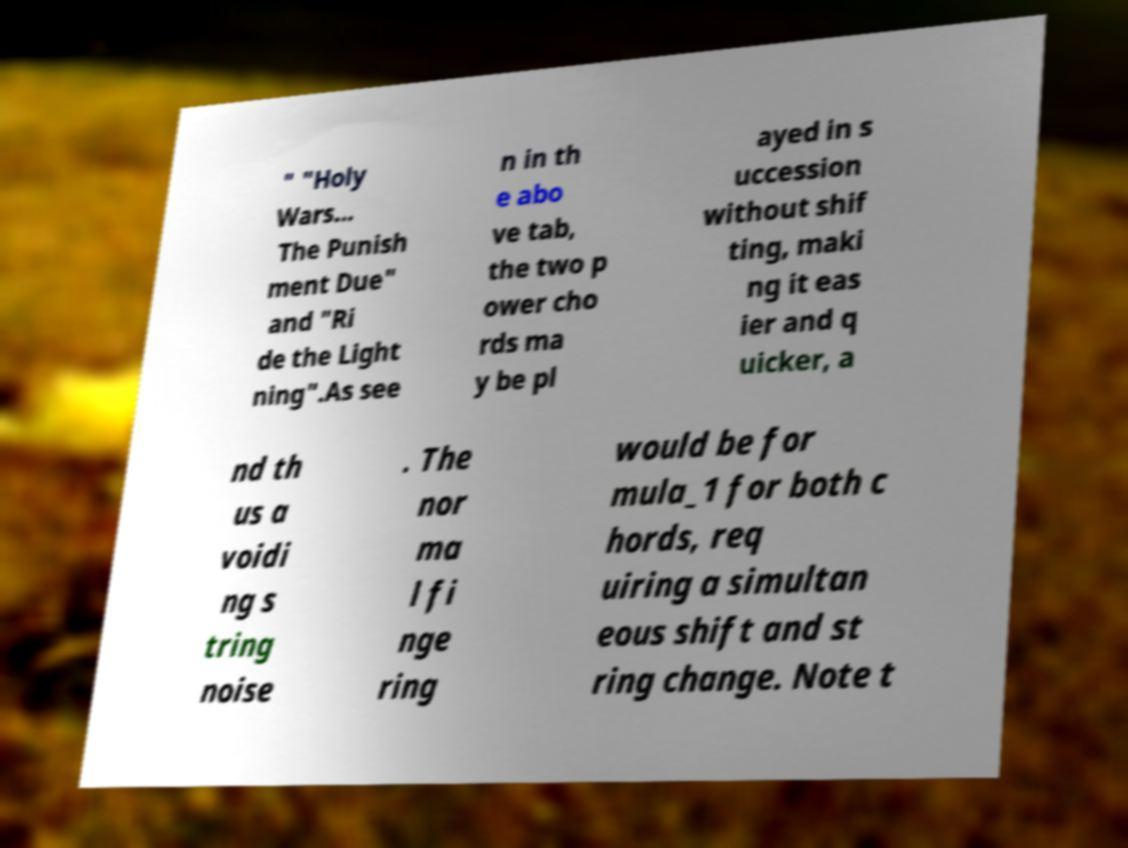Can you accurately transcribe the text from the provided image for me? " "Holy Wars... The Punish ment Due" and "Ri de the Light ning".As see n in th e abo ve tab, the two p ower cho rds ma y be pl ayed in s uccession without shif ting, maki ng it eas ier and q uicker, a nd th us a voidi ng s tring noise . The nor ma l fi nge ring would be for mula_1 for both c hords, req uiring a simultan eous shift and st ring change. Note t 